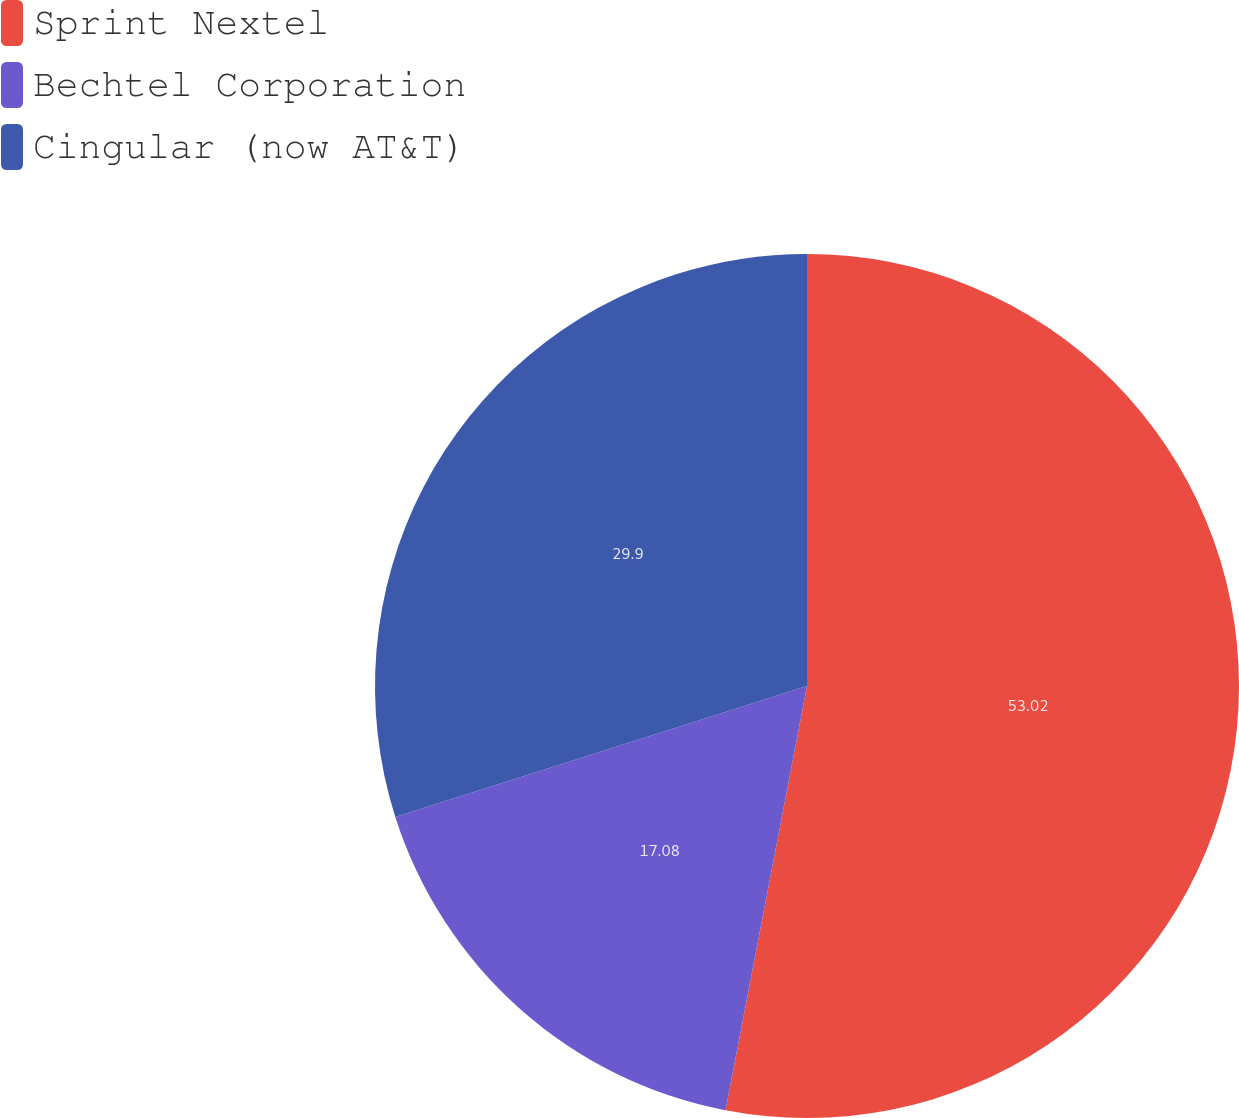<chart> <loc_0><loc_0><loc_500><loc_500><pie_chart><fcel>Sprint Nextel<fcel>Bechtel Corporation<fcel>Cingular (now AT&T)<nl><fcel>53.02%<fcel>17.08%<fcel>29.9%<nl></chart> 